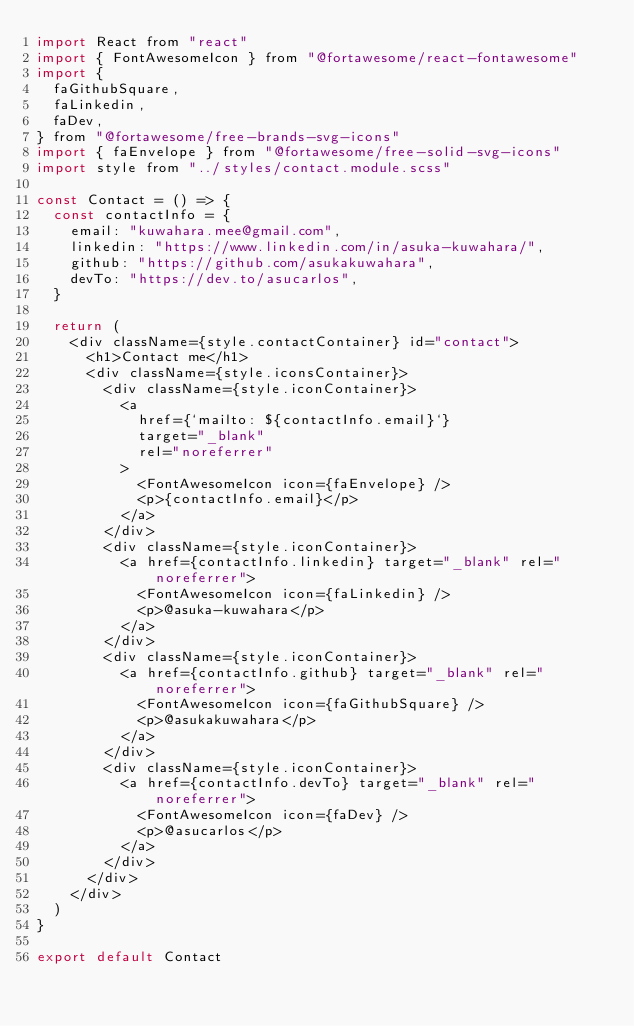Convert code to text. <code><loc_0><loc_0><loc_500><loc_500><_JavaScript_>import React from "react"
import { FontAwesomeIcon } from "@fortawesome/react-fontawesome"
import {
  faGithubSquare,
  faLinkedin,
  faDev,
} from "@fortawesome/free-brands-svg-icons"
import { faEnvelope } from "@fortawesome/free-solid-svg-icons"
import style from "../styles/contact.module.scss"

const Contact = () => {
  const contactInfo = {
    email: "kuwahara.mee@gmail.com",
    linkedin: "https://www.linkedin.com/in/asuka-kuwahara/",
    github: "https://github.com/asukakuwahara",
    devTo: "https://dev.to/asucarlos",
  }

  return (
    <div className={style.contactContainer} id="contact">
      <h1>Contact me</h1>
      <div className={style.iconsContainer}>
        <div className={style.iconContainer}>
          <a
            href={`mailto: ${contactInfo.email}`}
            target="_blank"
            rel="noreferrer"
          >
            <FontAwesomeIcon icon={faEnvelope} />
            <p>{contactInfo.email}</p>
          </a>
        </div>
        <div className={style.iconContainer}>
          <a href={contactInfo.linkedin} target="_blank" rel="noreferrer">
            <FontAwesomeIcon icon={faLinkedin} />
            <p>@asuka-kuwahara</p>
          </a>
        </div>
        <div className={style.iconContainer}>
          <a href={contactInfo.github} target="_blank" rel="noreferrer">
            <FontAwesomeIcon icon={faGithubSquare} />
            <p>@asukakuwahara</p>
          </a>
        </div>
        <div className={style.iconContainer}>
          <a href={contactInfo.devTo} target="_blank" rel="noreferrer">
            <FontAwesomeIcon icon={faDev} />
            <p>@asucarlos</p>
          </a>
        </div>
      </div>
    </div>
  )
}

export default Contact
</code> 